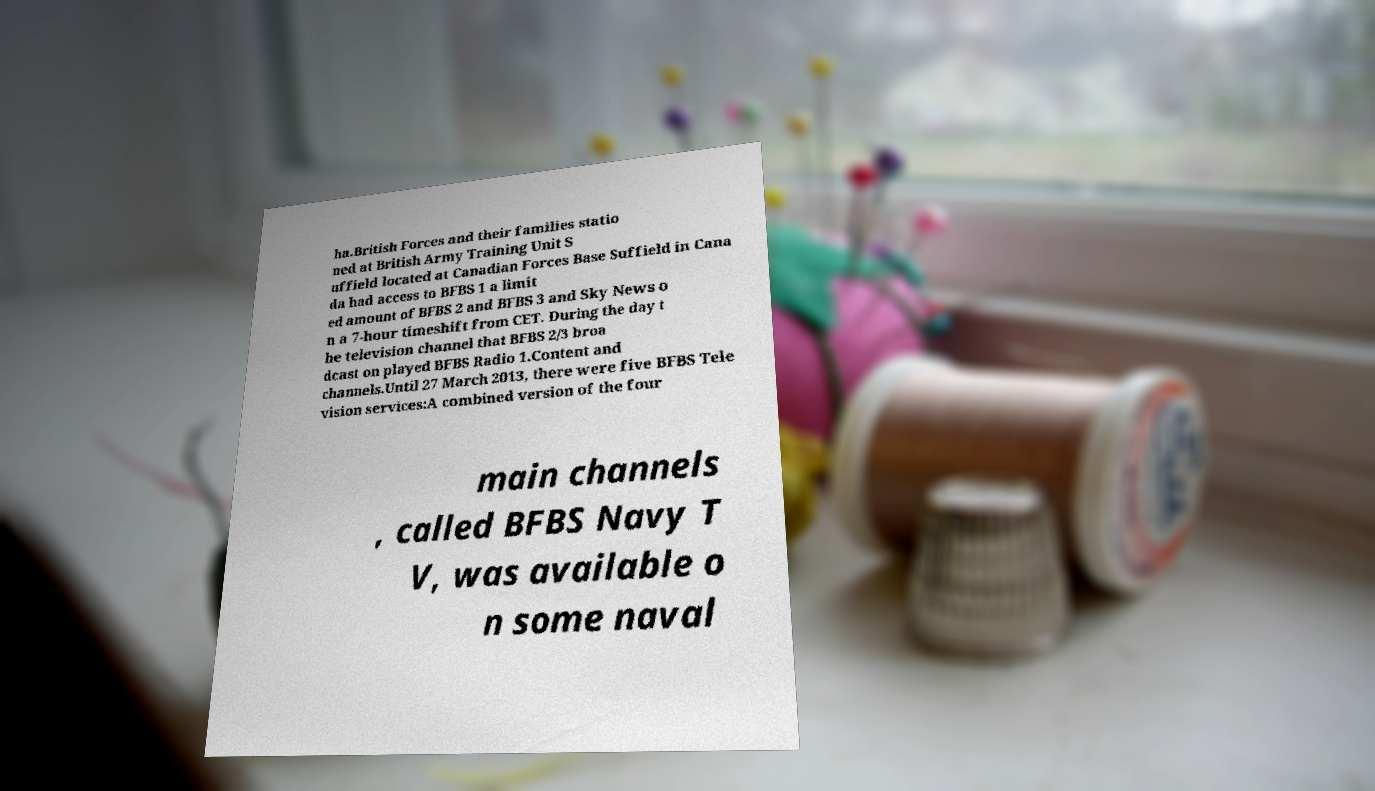Could you extract and type out the text from this image? ha.British Forces and their families statio ned at British Army Training Unit S uffield located at Canadian Forces Base Suffield in Cana da had access to BFBS 1 a limit ed amount of BFBS 2 and BFBS 3 and Sky News o n a 7-hour timeshift from CET. During the day t he television channel that BFBS 2/3 broa dcast on played BFBS Radio 1.Content and channels.Until 27 March 2013, there were five BFBS Tele vision services:A combined version of the four main channels , called BFBS Navy T V, was available o n some naval 